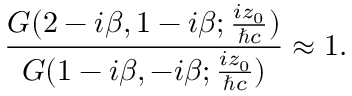Convert formula to latex. <formula><loc_0><loc_0><loc_500><loc_500>\frac { G ( 2 - i { \beta } , 1 - i { \beta } ; \frac { i z _ { 0 } } { { } c } ) } { G ( 1 - i { \beta } , - i { \beta } ; \frac { i z _ { 0 } } { { } c } ) } \approx 1 .</formula> 